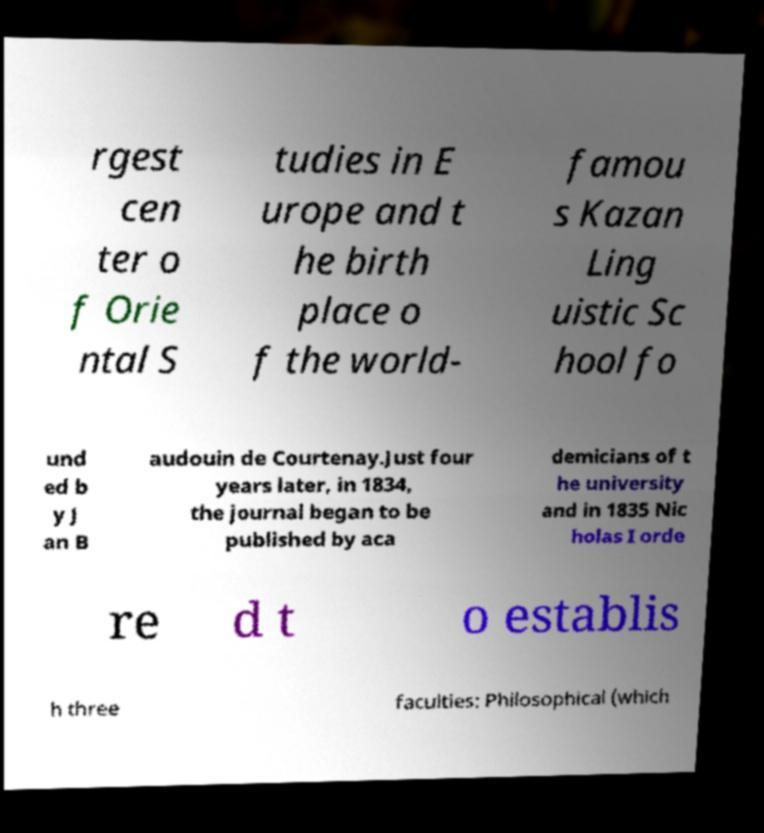What messages or text are displayed in this image? I need them in a readable, typed format. rgest cen ter o f Orie ntal S tudies in E urope and t he birth place o f the world- famou s Kazan Ling uistic Sc hool fo und ed b y J an B audouin de Courtenay.Just four years later, in 1834, the journal began to be published by aca demicians of t he university and in 1835 Nic holas I orde re d t o establis h three faculties: Philosophical (which 